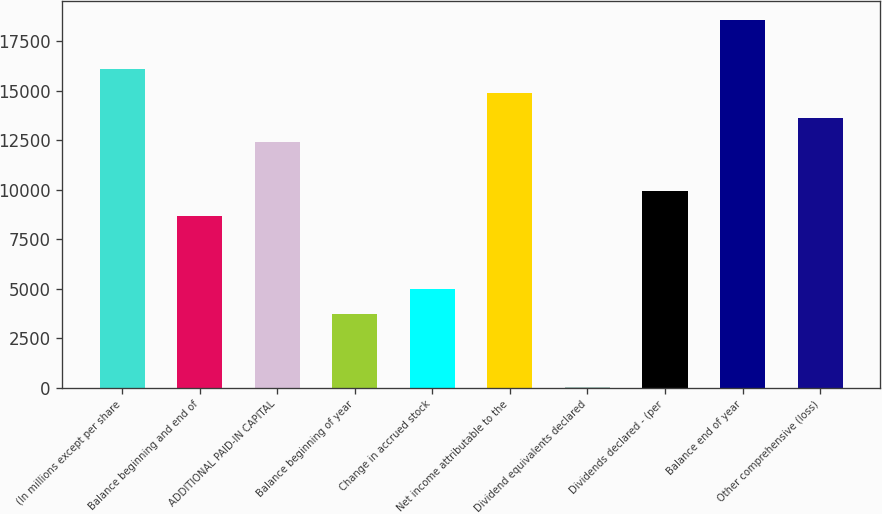Convert chart. <chart><loc_0><loc_0><loc_500><loc_500><bar_chart><fcel>(In millions except per share<fcel>Balance beginning and end of<fcel>ADDITIONAL PAID-IN CAPITAL<fcel>Balance beginning of year<fcel>Change in accrued stock<fcel>Net income attributable to the<fcel>Dividend equivalents declared<fcel>Dividends declared - (per<fcel>Balance end of year<fcel>Other comprehensive (loss)<nl><fcel>16102.3<fcel>8673.7<fcel>12388<fcel>3721.3<fcel>4959.4<fcel>14864.2<fcel>7<fcel>9911.8<fcel>18578.5<fcel>13626.1<nl></chart> 